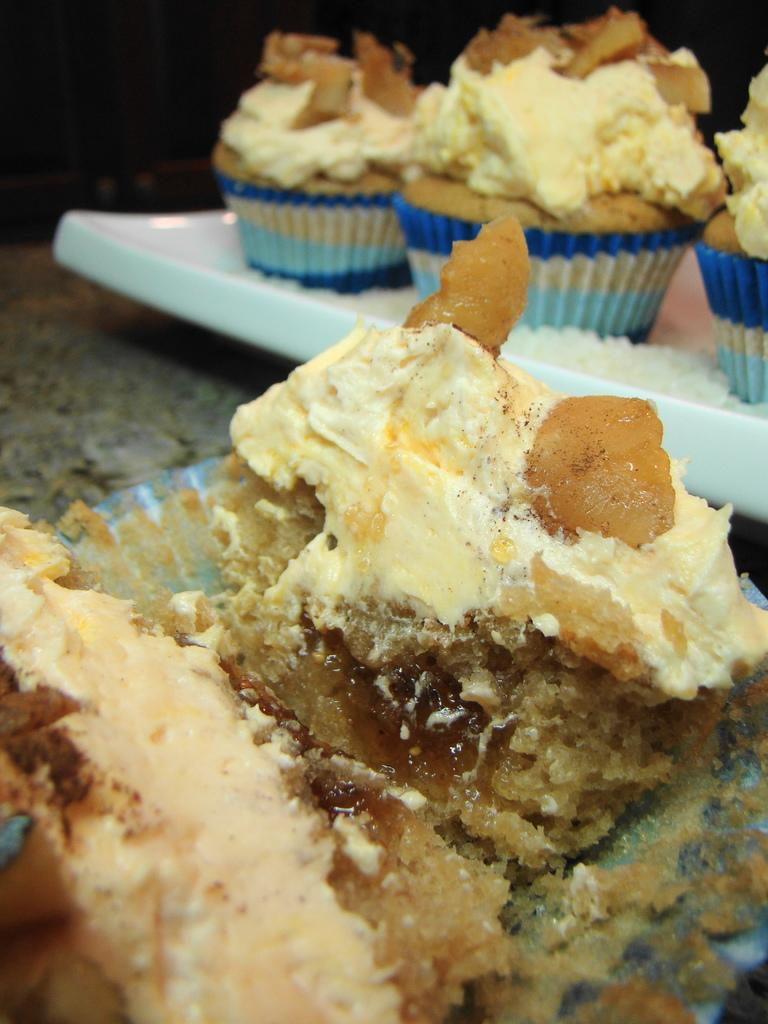What type of dessert can be seen in the image? There are cupcakes in the image. What color is the surface on which the cupcakes are placed? The cupcakes are on a white color surface. What other food items can be seen in the image? There is food visible on a grey color surface in front of the cupcakes. What type of tank is visible in the image? There is no tank present in the image; it features cupcakes on a white surface and food on a grey surface. 